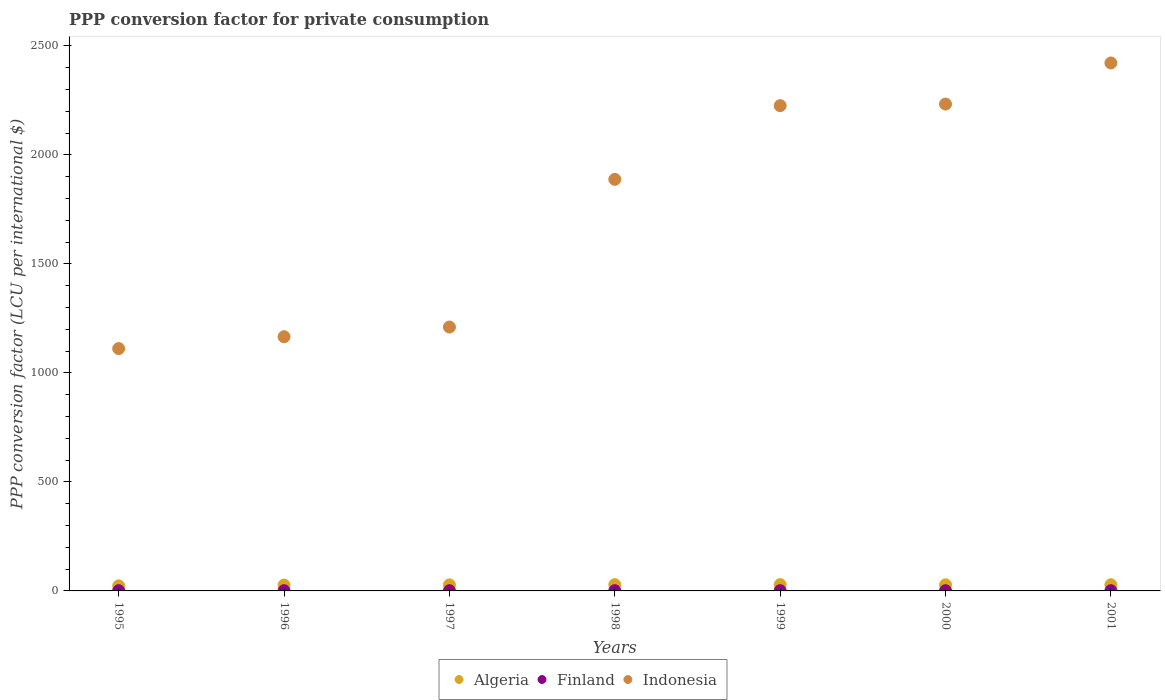What is the PPP conversion factor for private consumption in Finland in 1998?
Your answer should be compact. 1.09. Across all years, what is the maximum PPP conversion factor for private consumption in Indonesia?
Offer a terse response. 2421.77. Across all years, what is the minimum PPP conversion factor for private consumption in Algeria?
Ensure brevity in your answer.  23.3. In which year was the PPP conversion factor for private consumption in Finland maximum?
Ensure brevity in your answer.  2001. What is the total PPP conversion factor for private consumption in Finland in the graph?
Give a very brief answer. 7.65. What is the difference between the PPP conversion factor for private consumption in Algeria in 1995 and that in 1999?
Keep it short and to the point. -5.51. What is the difference between the PPP conversion factor for private consumption in Finland in 1999 and the PPP conversion factor for private consumption in Algeria in 1996?
Ensure brevity in your answer.  -25.78. What is the average PPP conversion factor for private consumption in Finland per year?
Provide a succinct answer. 1.09. In the year 2000, what is the difference between the PPP conversion factor for private consumption in Algeria and PPP conversion factor for private consumption in Finland?
Give a very brief answer. 26.89. What is the ratio of the PPP conversion factor for private consumption in Algeria in 1997 to that in 2001?
Provide a short and direct response. 0.98. Is the PPP conversion factor for private consumption in Indonesia in 1997 less than that in 2001?
Provide a succinct answer. Yes. What is the difference between the highest and the second highest PPP conversion factor for private consumption in Algeria?
Your response must be concise. 0.13. What is the difference between the highest and the lowest PPP conversion factor for private consumption in Indonesia?
Provide a succinct answer. 1310.1. Is the sum of the PPP conversion factor for private consumption in Algeria in 1996 and 1998 greater than the maximum PPP conversion factor for private consumption in Indonesia across all years?
Ensure brevity in your answer.  No. Does the PPP conversion factor for private consumption in Finland monotonically increase over the years?
Your response must be concise. No. Is the PPP conversion factor for private consumption in Algeria strictly greater than the PPP conversion factor for private consumption in Indonesia over the years?
Offer a terse response. No. Is the PPP conversion factor for private consumption in Finland strictly less than the PPP conversion factor for private consumption in Indonesia over the years?
Your response must be concise. Yes. How many years are there in the graph?
Offer a very short reply. 7. Are the values on the major ticks of Y-axis written in scientific E-notation?
Your answer should be very brief. No. Does the graph contain any zero values?
Offer a very short reply. No. How many legend labels are there?
Provide a short and direct response. 3. How are the legend labels stacked?
Make the answer very short. Horizontal. What is the title of the graph?
Your answer should be compact. PPP conversion factor for private consumption. Does "Vietnam" appear as one of the legend labels in the graph?
Keep it short and to the point. No. What is the label or title of the X-axis?
Make the answer very short. Years. What is the label or title of the Y-axis?
Provide a short and direct response. PPP conversion factor (LCU per international $). What is the PPP conversion factor (LCU per international $) of Algeria in 1995?
Ensure brevity in your answer.  23.3. What is the PPP conversion factor (LCU per international $) in Finland in 1995?
Your answer should be compact. 1.1. What is the PPP conversion factor (LCU per international $) of Indonesia in 1995?
Keep it short and to the point. 1111.67. What is the PPP conversion factor (LCU per international $) in Algeria in 1996?
Give a very brief answer. 26.87. What is the PPP conversion factor (LCU per international $) in Finland in 1996?
Keep it short and to the point. 1.09. What is the PPP conversion factor (LCU per international $) in Indonesia in 1996?
Ensure brevity in your answer.  1166.07. What is the PPP conversion factor (LCU per international $) of Algeria in 1997?
Make the answer very short. 27.76. What is the PPP conversion factor (LCU per international $) in Finland in 1997?
Give a very brief answer. 1.09. What is the PPP conversion factor (LCU per international $) in Indonesia in 1997?
Offer a very short reply. 1210.42. What is the PPP conversion factor (LCU per international $) of Algeria in 1998?
Ensure brevity in your answer.  28.69. What is the PPP conversion factor (LCU per international $) of Finland in 1998?
Provide a short and direct response. 1.09. What is the PPP conversion factor (LCU per international $) of Indonesia in 1998?
Your response must be concise. 1887.85. What is the PPP conversion factor (LCU per international $) of Algeria in 1999?
Your answer should be compact. 28.82. What is the PPP conversion factor (LCU per international $) in Finland in 1999?
Provide a succinct answer. 1.09. What is the PPP conversion factor (LCU per international $) of Indonesia in 1999?
Give a very brief answer. 2225.95. What is the PPP conversion factor (LCU per international $) in Algeria in 2000?
Make the answer very short. 27.97. What is the PPP conversion factor (LCU per international $) of Finland in 2000?
Give a very brief answer. 1.08. What is the PPP conversion factor (LCU per international $) in Indonesia in 2000?
Make the answer very short. 2233.34. What is the PPP conversion factor (LCU per international $) of Algeria in 2001?
Make the answer very short. 28.35. What is the PPP conversion factor (LCU per international $) of Finland in 2001?
Provide a short and direct response. 1.1. What is the PPP conversion factor (LCU per international $) of Indonesia in 2001?
Offer a very short reply. 2421.77. Across all years, what is the maximum PPP conversion factor (LCU per international $) of Algeria?
Offer a very short reply. 28.82. Across all years, what is the maximum PPP conversion factor (LCU per international $) in Finland?
Your response must be concise. 1.1. Across all years, what is the maximum PPP conversion factor (LCU per international $) of Indonesia?
Your answer should be compact. 2421.77. Across all years, what is the minimum PPP conversion factor (LCU per international $) in Algeria?
Ensure brevity in your answer.  23.3. Across all years, what is the minimum PPP conversion factor (LCU per international $) of Finland?
Give a very brief answer. 1.08. Across all years, what is the minimum PPP conversion factor (LCU per international $) of Indonesia?
Make the answer very short. 1111.67. What is the total PPP conversion factor (LCU per international $) in Algeria in the graph?
Offer a terse response. 191.75. What is the total PPP conversion factor (LCU per international $) of Finland in the graph?
Provide a succinct answer. 7.65. What is the total PPP conversion factor (LCU per international $) of Indonesia in the graph?
Your answer should be compact. 1.23e+04. What is the difference between the PPP conversion factor (LCU per international $) of Algeria in 1995 and that in 1996?
Give a very brief answer. -3.56. What is the difference between the PPP conversion factor (LCU per international $) of Finland in 1995 and that in 1996?
Your answer should be very brief. 0.01. What is the difference between the PPP conversion factor (LCU per international $) of Indonesia in 1995 and that in 1996?
Your response must be concise. -54.4. What is the difference between the PPP conversion factor (LCU per international $) in Algeria in 1995 and that in 1997?
Your response must be concise. -4.46. What is the difference between the PPP conversion factor (LCU per international $) of Finland in 1995 and that in 1997?
Offer a terse response. 0.02. What is the difference between the PPP conversion factor (LCU per international $) of Indonesia in 1995 and that in 1997?
Provide a short and direct response. -98.75. What is the difference between the PPP conversion factor (LCU per international $) in Algeria in 1995 and that in 1998?
Your answer should be very brief. -5.39. What is the difference between the PPP conversion factor (LCU per international $) of Finland in 1995 and that in 1998?
Ensure brevity in your answer.  0.01. What is the difference between the PPP conversion factor (LCU per international $) in Indonesia in 1995 and that in 1998?
Your response must be concise. -776.18. What is the difference between the PPP conversion factor (LCU per international $) of Algeria in 1995 and that in 1999?
Offer a terse response. -5.51. What is the difference between the PPP conversion factor (LCU per international $) of Finland in 1995 and that in 1999?
Offer a terse response. 0.02. What is the difference between the PPP conversion factor (LCU per international $) in Indonesia in 1995 and that in 1999?
Your answer should be compact. -1114.28. What is the difference between the PPP conversion factor (LCU per international $) of Algeria in 1995 and that in 2000?
Your answer should be very brief. -4.67. What is the difference between the PPP conversion factor (LCU per international $) in Finland in 1995 and that in 2000?
Provide a succinct answer. 0.02. What is the difference between the PPP conversion factor (LCU per international $) in Indonesia in 1995 and that in 2000?
Make the answer very short. -1121.67. What is the difference between the PPP conversion factor (LCU per international $) of Algeria in 1995 and that in 2001?
Keep it short and to the point. -5.05. What is the difference between the PPP conversion factor (LCU per international $) in Finland in 1995 and that in 2001?
Offer a very short reply. -0. What is the difference between the PPP conversion factor (LCU per international $) of Indonesia in 1995 and that in 2001?
Ensure brevity in your answer.  -1310.1. What is the difference between the PPP conversion factor (LCU per international $) in Algeria in 1996 and that in 1997?
Your response must be concise. -0.89. What is the difference between the PPP conversion factor (LCU per international $) in Finland in 1996 and that in 1997?
Your answer should be compact. 0.01. What is the difference between the PPP conversion factor (LCU per international $) in Indonesia in 1996 and that in 1997?
Your answer should be very brief. -44.35. What is the difference between the PPP conversion factor (LCU per international $) of Algeria in 1996 and that in 1998?
Your response must be concise. -1.82. What is the difference between the PPP conversion factor (LCU per international $) of Finland in 1996 and that in 1998?
Your response must be concise. -0. What is the difference between the PPP conversion factor (LCU per international $) of Indonesia in 1996 and that in 1998?
Keep it short and to the point. -721.78. What is the difference between the PPP conversion factor (LCU per international $) of Algeria in 1996 and that in 1999?
Your response must be concise. -1.95. What is the difference between the PPP conversion factor (LCU per international $) of Finland in 1996 and that in 1999?
Keep it short and to the point. 0.01. What is the difference between the PPP conversion factor (LCU per international $) of Indonesia in 1996 and that in 1999?
Your response must be concise. -1059.87. What is the difference between the PPP conversion factor (LCU per international $) in Algeria in 1996 and that in 2000?
Ensure brevity in your answer.  -1.1. What is the difference between the PPP conversion factor (LCU per international $) of Finland in 1996 and that in 2000?
Provide a short and direct response. 0.01. What is the difference between the PPP conversion factor (LCU per international $) in Indonesia in 1996 and that in 2000?
Make the answer very short. -1067.26. What is the difference between the PPP conversion factor (LCU per international $) of Algeria in 1996 and that in 2001?
Provide a succinct answer. -1.48. What is the difference between the PPP conversion factor (LCU per international $) of Finland in 1996 and that in 2001?
Give a very brief answer. -0.01. What is the difference between the PPP conversion factor (LCU per international $) of Indonesia in 1996 and that in 2001?
Offer a terse response. -1255.7. What is the difference between the PPP conversion factor (LCU per international $) of Algeria in 1997 and that in 1998?
Ensure brevity in your answer.  -0.93. What is the difference between the PPP conversion factor (LCU per international $) of Finland in 1997 and that in 1998?
Give a very brief answer. -0.01. What is the difference between the PPP conversion factor (LCU per international $) in Indonesia in 1997 and that in 1998?
Give a very brief answer. -677.43. What is the difference between the PPP conversion factor (LCU per international $) in Algeria in 1997 and that in 1999?
Your answer should be very brief. -1.06. What is the difference between the PPP conversion factor (LCU per international $) of Indonesia in 1997 and that in 1999?
Ensure brevity in your answer.  -1015.52. What is the difference between the PPP conversion factor (LCU per international $) of Algeria in 1997 and that in 2000?
Make the answer very short. -0.21. What is the difference between the PPP conversion factor (LCU per international $) of Finland in 1997 and that in 2000?
Give a very brief answer. 0.01. What is the difference between the PPP conversion factor (LCU per international $) in Indonesia in 1997 and that in 2000?
Give a very brief answer. -1022.91. What is the difference between the PPP conversion factor (LCU per international $) in Algeria in 1997 and that in 2001?
Your answer should be compact. -0.59. What is the difference between the PPP conversion factor (LCU per international $) of Finland in 1997 and that in 2001?
Your response must be concise. -0.02. What is the difference between the PPP conversion factor (LCU per international $) of Indonesia in 1997 and that in 2001?
Your answer should be very brief. -1211.35. What is the difference between the PPP conversion factor (LCU per international $) of Algeria in 1998 and that in 1999?
Make the answer very short. -0.13. What is the difference between the PPP conversion factor (LCU per international $) in Finland in 1998 and that in 1999?
Provide a succinct answer. 0.01. What is the difference between the PPP conversion factor (LCU per international $) in Indonesia in 1998 and that in 1999?
Keep it short and to the point. -338.1. What is the difference between the PPP conversion factor (LCU per international $) in Algeria in 1998 and that in 2000?
Provide a succinct answer. 0.72. What is the difference between the PPP conversion factor (LCU per international $) of Finland in 1998 and that in 2000?
Offer a very short reply. 0.01. What is the difference between the PPP conversion factor (LCU per international $) of Indonesia in 1998 and that in 2000?
Your response must be concise. -345.49. What is the difference between the PPP conversion factor (LCU per international $) in Algeria in 1998 and that in 2001?
Ensure brevity in your answer.  0.34. What is the difference between the PPP conversion factor (LCU per international $) of Finland in 1998 and that in 2001?
Offer a very short reply. -0.01. What is the difference between the PPP conversion factor (LCU per international $) in Indonesia in 1998 and that in 2001?
Provide a short and direct response. -533.93. What is the difference between the PPP conversion factor (LCU per international $) in Algeria in 1999 and that in 2000?
Offer a very short reply. 0.85. What is the difference between the PPP conversion factor (LCU per international $) of Finland in 1999 and that in 2000?
Provide a short and direct response. 0.01. What is the difference between the PPP conversion factor (LCU per international $) in Indonesia in 1999 and that in 2000?
Offer a very short reply. -7.39. What is the difference between the PPP conversion factor (LCU per international $) in Algeria in 1999 and that in 2001?
Ensure brevity in your answer.  0.47. What is the difference between the PPP conversion factor (LCU per international $) in Finland in 1999 and that in 2001?
Make the answer very short. -0.02. What is the difference between the PPP conversion factor (LCU per international $) in Indonesia in 1999 and that in 2001?
Your response must be concise. -195.83. What is the difference between the PPP conversion factor (LCU per international $) of Algeria in 2000 and that in 2001?
Provide a short and direct response. -0.38. What is the difference between the PPP conversion factor (LCU per international $) of Finland in 2000 and that in 2001?
Your answer should be very brief. -0.02. What is the difference between the PPP conversion factor (LCU per international $) of Indonesia in 2000 and that in 2001?
Offer a terse response. -188.44. What is the difference between the PPP conversion factor (LCU per international $) of Algeria in 1995 and the PPP conversion factor (LCU per international $) of Finland in 1996?
Your answer should be very brief. 22.21. What is the difference between the PPP conversion factor (LCU per international $) in Algeria in 1995 and the PPP conversion factor (LCU per international $) in Indonesia in 1996?
Ensure brevity in your answer.  -1142.77. What is the difference between the PPP conversion factor (LCU per international $) of Finland in 1995 and the PPP conversion factor (LCU per international $) of Indonesia in 1996?
Offer a terse response. -1164.97. What is the difference between the PPP conversion factor (LCU per international $) in Algeria in 1995 and the PPP conversion factor (LCU per international $) in Finland in 1997?
Your answer should be very brief. 22.21. What is the difference between the PPP conversion factor (LCU per international $) in Algeria in 1995 and the PPP conversion factor (LCU per international $) in Indonesia in 1997?
Your answer should be compact. -1187.12. What is the difference between the PPP conversion factor (LCU per international $) in Finland in 1995 and the PPP conversion factor (LCU per international $) in Indonesia in 1997?
Ensure brevity in your answer.  -1209.32. What is the difference between the PPP conversion factor (LCU per international $) in Algeria in 1995 and the PPP conversion factor (LCU per international $) in Finland in 1998?
Offer a very short reply. 22.21. What is the difference between the PPP conversion factor (LCU per international $) of Algeria in 1995 and the PPP conversion factor (LCU per international $) of Indonesia in 1998?
Your response must be concise. -1864.55. What is the difference between the PPP conversion factor (LCU per international $) of Finland in 1995 and the PPP conversion factor (LCU per international $) of Indonesia in 1998?
Ensure brevity in your answer.  -1886.75. What is the difference between the PPP conversion factor (LCU per international $) in Algeria in 1995 and the PPP conversion factor (LCU per international $) in Finland in 1999?
Offer a terse response. 22.21. What is the difference between the PPP conversion factor (LCU per international $) in Algeria in 1995 and the PPP conversion factor (LCU per international $) in Indonesia in 1999?
Provide a short and direct response. -2202.65. What is the difference between the PPP conversion factor (LCU per international $) of Finland in 1995 and the PPP conversion factor (LCU per international $) of Indonesia in 1999?
Your answer should be compact. -2224.85. What is the difference between the PPP conversion factor (LCU per international $) in Algeria in 1995 and the PPP conversion factor (LCU per international $) in Finland in 2000?
Offer a terse response. 22.22. What is the difference between the PPP conversion factor (LCU per international $) of Algeria in 1995 and the PPP conversion factor (LCU per international $) of Indonesia in 2000?
Your response must be concise. -2210.03. What is the difference between the PPP conversion factor (LCU per international $) in Finland in 1995 and the PPP conversion factor (LCU per international $) in Indonesia in 2000?
Your response must be concise. -2232.23. What is the difference between the PPP conversion factor (LCU per international $) of Algeria in 1995 and the PPP conversion factor (LCU per international $) of Finland in 2001?
Your response must be concise. 22.2. What is the difference between the PPP conversion factor (LCU per international $) of Algeria in 1995 and the PPP conversion factor (LCU per international $) of Indonesia in 2001?
Your response must be concise. -2398.47. What is the difference between the PPP conversion factor (LCU per international $) in Finland in 1995 and the PPP conversion factor (LCU per international $) in Indonesia in 2001?
Your answer should be very brief. -2420.67. What is the difference between the PPP conversion factor (LCU per international $) in Algeria in 1996 and the PPP conversion factor (LCU per international $) in Finland in 1997?
Your response must be concise. 25.78. What is the difference between the PPP conversion factor (LCU per international $) in Algeria in 1996 and the PPP conversion factor (LCU per international $) in Indonesia in 1997?
Offer a very short reply. -1183.56. What is the difference between the PPP conversion factor (LCU per international $) of Finland in 1996 and the PPP conversion factor (LCU per international $) of Indonesia in 1997?
Your answer should be compact. -1209.33. What is the difference between the PPP conversion factor (LCU per international $) of Algeria in 1996 and the PPP conversion factor (LCU per international $) of Finland in 1998?
Offer a terse response. 25.77. What is the difference between the PPP conversion factor (LCU per international $) in Algeria in 1996 and the PPP conversion factor (LCU per international $) in Indonesia in 1998?
Make the answer very short. -1860.98. What is the difference between the PPP conversion factor (LCU per international $) of Finland in 1996 and the PPP conversion factor (LCU per international $) of Indonesia in 1998?
Your answer should be very brief. -1886.76. What is the difference between the PPP conversion factor (LCU per international $) in Algeria in 1996 and the PPP conversion factor (LCU per international $) in Finland in 1999?
Make the answer very short. 25.78. What is the difference between the PPP conversion factor (LCU per international $) in Algeria in 1996 and the PPP conversion factor (LCU per international $) in Indonesia in 1999?
Give a very brief answer. -2199.08. What is the difference between the PPP conversion factor (LCU per international $) in Finland in 1996 and the PPP conversion factor (LCU per international $) in Indonesia in 1999?
Give a very brief answer. -2224.85. What is the difference between the PPP conversion factor (LCU per international $) in Algeria in 1996 and the PPP conversion factor (LCU per international $) in Finland in 2000?
Offer a very short reply. 25.79. What is the difference between the PPP conversion factor (LCU per international $) in Algeria in 1996 and the PPP conversion factor (LCU per international $) in Indonesia in 2000?
Make the answer very short. -2206.47. What is the difference between the PPP conversion factor (LCU per international $) of Finland in 1996 and the PPP conversion factor (LCU per international $) of Indonesia in 2000?
Make the answer very short. -2232.24. What is the difference between the PPP conversion factor (LCU per international $) of Algeria in 1996 and the PPP conversion factor (LCU per international $) of Finland in 2001?
Provide a succinct answer. 25.76. What is the difference between the PPP conversion factor (LCU per international $) of Algeria in 1996 and the PPP conversion factor (LCU per international $) of Indonesia in 2001?
Your answer should be compact. -2394.91. What is the difference between the PPP conversion factor (LCU per international $) of Finland in 1996 and the PPP conversion factor (LCU per international $) of Indonesia in 2001?
Make the answer very short. -2420.68. What is the difference between the PPP conversion factor (LCU per international $) of Algeria in 1997 and the PPP conversion factor (LCU per international $) of Finland in 1998?
Keep it short and to the point. 26.66. What is the difference between the PPP conversion factor (LCU per international $) in Algeria in 1997 and the PPP conversion factor (LCU per international $) in Indonesia in 1998?
Provide a succinct answer. -1860.09. What is the difference between the PPP conversion factor (LCU per international $) in Finland in 1997 and the PPP conversion factor (LCU per international $) in Indonesia in 1998?
Give a very brief answer. -1886.76. What is the difference between the PPP conversion factor (LCU per international $) in Algeria in 1997 and the PPP conversion factor (LCU per international $) in Finland in 1999?
Provide a short and direct response. 26.67. What is the difference between the PPP conversion factor (LCU per international $) in Algeria in 1997 and the PPP conversion factor (LCU per international $) in Indonesia in 1999?
Make the answer very short. -2198.19. What is the difference between the PPP conversion factor (LCU per international $) in Finland in 1997 and the PPP conversion factor (LCU per international $) in Indonesia in 1999?
Your response must be concise. -2224.86. What is the difference between the PPP conversion factor (LCU per international $) in Algeria in 1997 and the PPP conversion factor (LCU per international $) in Finland in 2000?
Offer a very short reply. 26.68. What is the difference between the PPP conversion factor (LCU per international $) of Algeria in 1997 and the PPP conversion factor (LCU per international $) of Indonesia in 2000?
Offer a terse response. -2205.58. What is the difference between the PPP conversion factor (LCU per international $) in Finland in 1997 and the PPP conversion factor (LCU per international $) in Indonesia in 2000?
Provide a succinct answer. -2232.25. What is the difference between the PPP conversion factor (LCU per international $) in Algeria in 1997 and the PPP conversion factor (LCU per international $) in Finland in 2001?
Make the answer very short. 26.65. What is the difference between the PPP conversion factor (LCU per international $) in Algeria in 1997 and the PPP conversion factor (LCU per international $) in Indonesia in 2001?
Your answer should be compact. -2394.02. What is the difference between the PPP conversion factor (LCU per international $) in Finland in 1997 and the PPP conversion factor (LCU per international $) in Indonesia in 2001?
Your answer should be very brief. -2420.69. What is the difference between the PPP conversion factor (LCU per international $) of Algeria in 1998 and the PPP conversion factor (LCU per international $) of Finland in 1999?
Your answer should be very brief. 27.6. What is the difference between the PPP conversion factor (LCU per international $) of Algeria in 1998 and the PPP conversion factor (LCU per international $) of Indonesia in 1999?
Your response must be concise. -2197.26. What is the difference between the PPP conversion factor (LCU per international $) of Finland in 1998 and the PPP conversion factor (LCU per international $) of Indonesia in 1999?
Your response must be concise. -2224.85. What is the difference between the PPP conversion factor (LCU per international $) in Algeria in 1998 and the PPP conversion factor (LCU per international $) in Finland in 2000?
Your answer should be very brief. 27.61. What is the difference between the PPP conversion factor (LCU per international $) of Algeria in 1998 and the PPP conversion factor (LCU per international $) of Indonesia in 2000?
Offer a terse response. -2204.65. What is the difference between the PPP conversion factor (LCU per international $) in Finland in 1998 and the PPP conversion factor (LCU per international $) in Indonesia in 2000?
Offer a terse response. -2232.24. What is the difference between the PPP conversion factor (LCU per international $) of Algeria in 1998 and the PPP conversion factor (LCU per international $) of Finland in 2001?
Ensure brevity in your answer.  27.58. What is the difference between the PPP conversion factor (LCU per international $) of Algeria in 1998 and the PPP conversion factor (LCU per international $) of Indonesia in 2001?
Keep it short and to the point. -2393.09. What is the difference between the PPP conversion factor (LCU per international $) of Finland in 1998 and the PPP conversion factor (LCU per international $) of Indonesia in 2001?
Provide a succinct answer. -2420.68. What is the difference between the PPP conversion factor (LCU per international $) in Algeria in 1999 and the PPP conversion factor (LCU per international $) in Finland in 2000?
Offer a terse response. 27.73. What is the difference between the PPP conversion factor (LCU per international $) of Algeria in 1999 and the PPP conversion factor (LCU per international $) of Indonesia in 2000?
Offer a very short reply. -2204.52. What is the difference between the PPP conversion factor (LCU per international $) in Finland in 1999 and the PPP conversion factor (LCU per international $) in Indonesia in 2000?
Provide a short and direct response. -2232.25. What is the difference between the PPP conversion factor (LCU per international $) of Algeria in 1999 and the PPP conversion factor (LCU per international $) of Finland in 2001?
Your answer should be compact. 27.71. What is the difference between the PPP conversion factor (LCU per international $) of Algeria in 1999 and the PPP conversion factor (LCU per international $) of Indonesia in 2001?
Your answer should be compact. -2392.96. What is the difference between the PPP conversion factor (LCU per international $) in Finland in 1999 and the PPP conversion factor (LCU per international $) in Indonesia in 2001?
Make the answer very short. -2420.69. What is the difference between the PPP conversion factor (LCU per international $) of Algeria in 2000 and the PPP conversion factor (LCU per international $) of Finland in 2001?
Provide a short and direct response. 26.86. What is the difference between the PPP conversion factor (LCU per international $) of Algeria in 2000 and the PPP conversion factor (LCU per international $) of Indonesia in 2001?
Make the answer very short. -2393.8. What is the difference between the PPP conversion factor (LCU per international $) of Finland in 2000 and the PPP conversion factor (LCU per international $) of Indonesia in 2001?
Ensure brevity in your answer.  -2420.69. What is the average PPP conversion factor (LCU per international $) of Algeria per year?
Make the answer very short. 27.39. What is the average PPP conversion factor (LCU per international $) of Finland per year?
Provide a short and direct response. 1.09. What is the average PPP conversion factor (LCU per international $) of Indonesia per year?
Your answer should be compact. 1751.01. In the year 1995, what is the difference between the PPP conversion factor (LCU per international $) in Algeria and PPP conversion factor (LCU per international $) in Finland?
Provide a short and direct response. 22.2. In the year 1995, what is the difference between the PPP conversion factor (LCU per international $) of Algeria and PPP conversion factor (LCU per international $) of Indonesia?
Ensure brevity in your answer.  -1088.37. In the year 1995, what is the difference between the PPP conversion factor (LCU per international $) in Finland and PPP conversion factor (LCU per international $) in Indonesia?
Offer a terse response. -1110.57. In the year 1996, what is the difference between the PPP conversion factor (LCU per international $) of Algeria and PPP conversion factor (LCU per international $) of Finland?
Offer a very short reply. 25.77. In the year 1996, what is the difference between the PPP conversion factor (LCU per international $) in Algeria and PPP conversion factor (LCU per international $) in Indonesia?
Keep it short and to the point. -1139.21. In the year 1996, what is the difference between the PPP conversion factor (LCU per international $) of Finland and PPP conversion factor (LCU per international $) of Indonesia?
Ensure brevity in your answer.  -1164.98. In the year 1997, what is the difference between the PPP conversion factor (LCU per international $) of Algeria and PPP conversion factor (LCU per international $) of Finland?
Offer a terse response. 26.67. In the year 1997, what is the difference between the PPP conversion factor (LCU per international $) in Algeria and PPP conversion factor (LCU per international $) in Indonesia?
Make the answer very short. -1182.66. In the year 1997, what is the difference between the PPP conversion factor (LCU per international $) in Finland and PPP conversion factor (LCU per international $) in Indonesia?
Your response must be concise. -1209.34. In the year 1998, what is the difference between the PPP conversion factor (LCU per international $) of Algeria and PPP conversion factor (LCU per international $) of Finland?
Provide a short and direct response. 27.59. In the year 1998, what is the difference between the PPP conversion factor (LCU per international $) in Algeria and PPP conversion factor (LCU per international $) in Indonesia?
Offer a very short reply. -1859.16. In the year 1998, what is the difference between the PPP conversion factor (LCU per international $) in Finland and PPP conversion factor (LCU per international $) in Indonesia?
Offer a terse response. -1886.75. In the year 1999, what is the difference between the PPP conversion factor (LCU per international $) of Algeria and PPP conversion factor (LCU per international $) of Finland?
Provide a short and direct response. 27.73. In the year 1999, what is the difference between the PPP conversion factor (LCU per international $) in Algeria and PPP conversion factor (LCU per international $) in Indonesia?
Give a very brief answer. -2197.13. In the year 1999, what is the difference between the PPP conversion factor (LCU per international $) of Finland and PPP conversion factor (LCU per international $) of Indonesia?
Your response must be concise. -2224.86. In the year 2000, what is the difference between the PPP conversion factor (LCU per international $) of Algeria and PPP conversion factor (LCU per international $) of Finland?
Keep it short and to the point. 26.89. In the year 2000, what is the difference between the PPP conversion factor (LCU per international $) in Algeria and PPP conversion factor (LCU per international $) in Indonesia?
Provide a short and direct response. -2205.37. In the year 2000, what is the difference between the PPP conversion factor (LCU per international $) in Finland and PPP conversion factor (LCU per international $) in Indonesia?
Your answer should be compact. -2232.26. In the year 2001, what is the difference between the PPP conversion factor (LCU per international $) in Algeria and PPP conversion factor (LCU per international $) in Finland?
Ensure brevity in your answer.  27.24. In the year 2001, what is the difference between the PPP conversion factor (LCU per international $) in Algeria and PPP conversion factor (LCU per international $) in Indonesia?
Provide a short and direct response. -2393.42. In the year 2001, what is the difference between the PPP conversion factor (LCU per international $) of Finland and PPP conversion factor (LCU per international $) of Indonesia?
Provide a short and direct response. -2420.67. What is the ratio of the PPP conversion factor (LCU per international $) of Algeria in 1995 to that in 1996?
Your answer should be very brief. 0.87. What is the ratio of the PPP conversion factor (LCU per international $) in Finland in 1995 to that in 1996?
Your answer should be compact. 1.01. What is the ratio of the PPP conversion factor (LCU per international $) in Indonesia in 1995 to that in 1996?
Your answer should be very brief. 0.95. What is the ratio of the PPP conversion factor (LCU per international $) in Algeria in 1995 to that in 1997?
Provide a succinct answer. 0.84. What is the ratio of the PPP conversion factor (LCU per international $) of Finland in 1995 to that in 1997?
Ensure brevity in your answer.  1.01. What is the ratio of the PPP conversion factor (LCU per international $) of Indonesia in 1995 to that in 1997?
Your answer should be compact. 0.92. What is the ratio of the PPP conversion factor (LCU per international $) in Algeria in 1995 to that in 1998?
Offer a terse response. 0.81. What is the ratio of the PPP conversion factor (LCU per international $) of Finland in 1995 to that in 1998?
Ensure brevity in your answer.  1.01. What is the ratio of the PPP conversion factor (LCU per international $) in Indonesia in 1995 to that in 1998?
Your answer should be compact. 0.59. What is the ratio of the PPP conversion factor (LCU per international $) of Algeria in 1995 to that in 1999?
Make the answer very short. 0.81. What is the ratio of the PPP conversion factor (LCU per international $) in Finland in 1995 to that in 1999?
Keep it short and to the point. 1.01. What is the ratio of the PPP conversion factor (LCU per international $) in Indonesia in 1995 to that in 1999?
Provide a succinct answer. 0.5. What is the ratio of the PPP conversion factor (LCU per international $) in Algeria in 1995 to that in 2000?
Offer a very short reply. 0.83. What is the ratio of the PPP conversion factor (LCU per international $) in Finland in 1995 to that in 2000?
Provide a short and direct response. 1.02. What is the ratio of the PPP conversion factor (LCU per international $) of Indonesia in 1995 to that in 2000?
Your answer should be compact. 0.5. What is the ratio of the PPP conversion factor (LCU per international $) of Algeria in 1995 to that in 2001?
Provide a short and direct response. 0.82. What is the ratio of the PPP conversion factor (LCU per international $) in Finland in 1995 to that in 2001?
Give a very brief answer. 1. What is the ratio of the PPP conversion factor (LCU per international $) in Indonesia in 1995 to that in 2001?
Your answer should be compact. 0.46. What is the ratio of the PPP conversion factor (LCU per international $) of Algeria in 1996 to that in 1997?
Your answer should be very brief. 0.97. What is the ratio of the PPP conversion factor (LCU per international $) in Indonesia in 1996 to that in 1997?
Provide a short and direct response. 0.96. What is the ratio of the PPP conversion factor (LCU per international $) of Algeria in 1996 to that in 1998?
Provide a succinct answer. 0.94. What is the ratio of the PPP conversion factor (LCU per international $) in Indonesia in 1996 to that in 1998?
Keep it short and to the point. 0.62. What is the ratio of the PPP conversion factor (LCU per international $) of Algeria in 1996 to that in 1999?
Provide a short and direct response. 0.93. What is the ratio of the PPP conversion factor (LCU per international $) in Indonesia in 1996 to that in 1999?
Keep it short and to the point. 0.52. What is the ratio of the PPP conversion factor (LCU per international $) in Algeria in 1996 to that in 2000?
Give a very brief answer. 0.96. What is the ratio of the PPP conversion factor (LCU per international $) of Finland in 1996 to that in 2000?
Provide a succinct answer. 1.01. What is the ratio of the PPP conversion factor (LCU per international $) of Indonesia in 1996 to that in 2000?
Keep it short and to the point. 0.52. What is the ratio of the PPP conversion factor (LCU per international $) of Algeria in 1996 to that in 2001?
Make the answer very short. 0.95. What is the ratio of the PPP conversion factor (LCU per international $) in Finland in 1996 to that in 2001?
Provide a succinct answer. 0.99. What is the ratio of the PPP conversion factor (LCU per international $) in Indonesia in 1996 to that in 2001?
Ensure brevity in your answer.  0.48. What is the ratio of the PPP conversion factor (LCU per international $) of Algeria in 1997 to that in 1998?
Provide a succinct answer. 0.97. What is the ratio of the PPP conversion factor (LCU per international $) in Finland in 1997 to that in 1998?
Offer a terse response. 0.99. What is the ratio of the PPP conversion factor (LCU per international $) of Indonesia in 1997 to that in 1998?
Give a very brief answer. 0.64. What is the ratio of the PPP conversion factor (LCU per international $) of Algeria in 1997 to that in 1999?
Offer a terse response. 0.96. What is the ratio of the PPP conversion factor (LCU per international $) of Finland in 1997 to that in 1999?
Keep it short and to the point. 1. What is the ratio of the PPP conversion factor (LCU per international $) of Indonesia in 1997 to that in 1999?
Your answer should be very brief. 0.54. What is the ratio of the PPP conversion factor (LCU per international $) in Finland in 1997 to that in 2000?
Your answer should be very brief. 1.01. What is the ratio of the PPP conversion factor (LCU per international $) of Indonesia in 1997 to that in 2000?
Offer a very short reply. 0.54. What is the ratio of the PPP conversion factor (LCU per international $) in Algeria in 1997 to that in 2001?
Your response must be concise. 0.98. What is the ratio of the PPP conversion factor (LCU per international $) of Indonesia in 1997 to that in 2001?
Your answer should be compact. 0.5. What is the ratio of the PPP conversion factor (LCU per international $) in Finland in 1998 to that in 1999?
Your answer should be very brief. 1.01. What is the ratio of the PPP conversion factor (LCU per international $) in Indonesia in 1998 to that in 1999?
Make the answer very short. 0.85. What is the ratio of the PPP conversion factor (LCU per international $) in Algeria in 1998 to that in 2000?
Make the answer very short. 1.03. What is the ratio of the PPP conversion factor (LCU per international $) in Finland in 1998 to that in 2000?
Your response must be concise. 1.01. What is the ratio of the PPP conversion factor (LCU per international $) of Indonesia in 1998 to that in 2000?
Offer a terse response. 0.85. What is the ratio of the PPP conversion factor (LCU per international $) in Algeria in 1998 to that in 2001?
Ensure brevity in your answer.  1.01. What is the ratio of the PPP conversion factor (LCU per international $) in Indonesia in 1998 to that in 2001?
Your answer should be compact. 0.78. What is the ratio of the PPP conversion factor (LCU per international $) in Algeria in 1999 to that in 2000?
Make the answer very short. 1.03. What is the ratio of the PPP conversion factor (LCU per international $) of Finland in 1999 to that in 2000?
Your response must be concise. 1.01. What is the ratio of the PPP conversion factor (LCU per international $) in Algeria in 1999 to that in 2001?
Your answer should be very brief. 1.02. What is the ratio of the PPP conversion factor (LCU per international $) of Finland in 1999 to that in 2001?
Your response must be concise. 0.98. What is the ratio of the PPP conversion factor (LCU per international $) in Indonesia in 1999 to that in 2001?
Offer a terse response. 0.92. What is the ratio of the PPP conversion factor (LCU per international $) of Algeria in 2000 to that in 2001?
Make the answer very short. 0.99. What is the ratio of the PPP conversion factor (LCU per international $) in Finland in 2000 to that in 2001?
Ensure brevity in your answer.  0.98. What is the ratio of the PPP conversion factor (LCU per international $) in Indonesia in 2000 to that in 2001?
Ensure brevity in your answer.  0.92. What is the difference between the highest and the second highest PPP conversion factor (LCU per international $) in Algeria?
Ensure brevity in your answer.  0.13. What is the difference between the highest and the second highest PPP conversion factor (LCU per international $) in Finland?
Offer a terse response. 0. What is the difference between the highest and the second highest PPP conversion factor (LCU per international $) in Indonesia?
Give a very brief answer. 188.44. What is the difference between the highest and the lowest PPP conversion factor (LCU per international $) of Algeria?
Provide a short and direct response. 5.51. What is the difference between the highest and the lowest PPP conversion factor (LCU per international $) in Finland?
Offer a terse response. 0.02. What is the difference between the highest and the lowest PPP conversion factor (LCU per international $) of Indonesia?
Your answer should be very brief. 1310.1. 